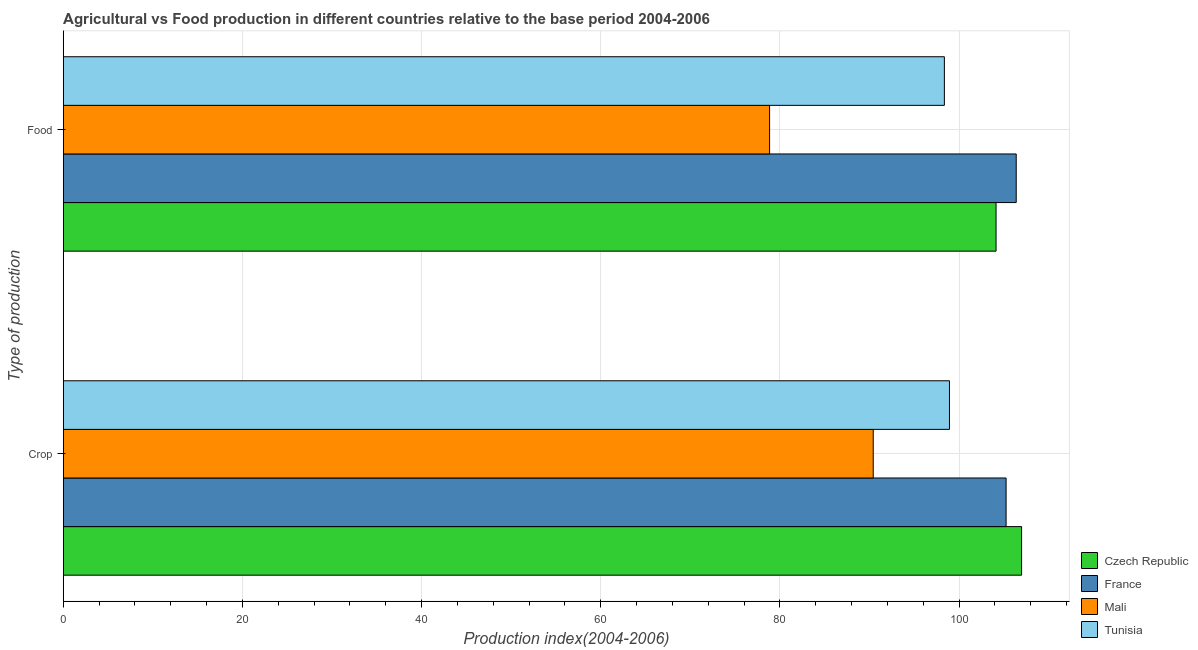Are the number of bars per tick equal to the number of legend labels?
Ensure brevity in your answer.  Yes. Are the number of bars on each tick of the Y-axis equal?
Offer a very short reply. Yes. How many bars are there on the 1st tick from the top?
Offer a terse response. 4. What is the label of the 1st group of bars from the top?
Provide a succinct answer. Food. What is the crop production index in France?
Ensure brevity in your answer.  105.25. Across all countries, what is the maximum food production index?
Offer a terse response. 106.38. Across all countries, what is the minimum food production index?
Your answer should be compact. 78.85. In which country was the food production index maximum?
Provide a short and direct response. France. In which country was the food production index minimum?
Provide a short and direct response. Mali. What is the total crop production index in the graph?
Provide a succinct answer. 401.58. What is the difference between the crop production index in Tunisia and that in Mali?
Make the answer very short. 8.51. What is the difference between the crop production index in Czech Republic and the food production index in France?
Your answer should be compact. 0.6. What is the average food production index per country?
Your response must be concise. 96.93. What is the difference between the crop production index and food production index in Czech Republic?
Offer a terse response. 2.85. In how many countries, is the crop production index greater than 108 ?
Make the answer very short. 0. What is the ratio of the crop production index in France to that in Tunisia?
Give a very brief answer. 1.06. What does the 1st bar from the top in Crop represents?
Your response must be concise. Tunisia. What does the 2nd bar from the bottom in Crop represents?
Provide a succinct answer. France. Are all the bars in the graph horizontal?
Your answer should be very brief. Yes. How many countries are there in the graph?
Your answer should be very brief. 4. What is the difference between two consecutive major ticks on the X-axis?
Provide a short and direct response. 20. Are the values on the major ticks of X-axis written in scientific E-notation?
Give a very brief answer. No. Does the graph contain any zero values?
Your response must be concise. No. Does the graph contain grids?
Offer a very short reply. Yes. How many legend labels are there?
Keep it short and to the point. 4. How are the legend labels stacked?
Offer a very short reply. Vertical. What is the title of the graph?
Ensure brevity in your answer.  Agricultural vs Food production in different countries relative to the base period 2004-2006. Does "Zambia" appear as one of the legend labels in the graph?
Provide a short and direct response. No. What is the label or title of the X-axis?
Keep it short and to the point. Production index(2004-2006). What is the label or title of the Y-axis?
Provide a succinct answer. Type of production. What is the Production index(2004-2006) of Czech Republic in Crop?
Offer a very short reply. 106.98. What is the Production index(2004-2006) of France in Crop?
Keep it short and to the point. 105.25. What is the Production index(2004-2006) of Mali in Crop?
Keep it short and to the point. 90.42. What is the Production index(2004-2006) in Tunisia in Crop?
Ensure brevity in your answer.  98.93. What is the Production index(2004-2006) in Czech Republic in Food?
Your answer should be compact. 104.13. What is the Production index(2004-2006) of France in Food?
Offer a very short reply. 106.38. What is the Production index(2004-2006) in Mali in Food?
Ensure brevity in your answer.  78.85. What is the Production index(2004-2006) of Tunisia in Food?
Your response must be concise. 98.36. Across all Type of production, what is the maximum Production index(2004-2006) of Czech Republic?
Provide a succinct answer. 106.98. Across all Type of production, what is the maximum Production index(2004-2006) of France?
Ensure brevity in your answer.  106.38. Across all Type of production, what is the maximum Production index(2004-2006) in Mali?
Provide a succinct answer. 90.42. Across all Type of production, what is the maximum Production index(2004-2006) of Tunisia?
Provide a succinct answer. 98.93. Across all Type of production, what is the minimum Production index(2004-2006) in Czech Republic?
Make the answer very short. 104.13. Across all Type of production, what is the minimum Production index(2004-2006) in France?
Your answer should be very brief. 105.25. Across all Type of production, what is the minimum Production index(2004-2006) of Mali?
Provide a succinct answer. 78.85. Across all Type of production, what is the minimum Production index(2004-2006) of Tunisia?
Offer a terse response. 98.36. What is the total Production index(2004-2006) of Czech Republic in the graph?
Provide a short and direct response. 211.11. What is the total Production index(2004-2006) of France in the graph?
Keep it short and to the point. 211.63. What is the total Production index(2004-2006) of Mali in the graph?
Keep it short and to the point. 169.27. What is the total Production index(2004-2006) of Tunisia in the graph?
Keep it short and to the point. 197.29. What is the difference between the Production index(2004-2006) of Czech Republic in Crop and that in Food?
Offer a very short reply. 2.85. What is the difference between the Production index(2004-2006) in France in Crop and that in Food?
Your answer should be compact. -1.13. What is the difference between the Production index(2004-2006) of Mali in Crop and that in Food?
Give a very brief answer. 11.57. What is the difference between the Production index(2004-2006) of Tunisia in Crop and that in Food?
Offer a terse response. 0.57. What is the difference between the Production index(2004-2006) of Czech Republic in Crop and the Production index(2004-2006) of Mali in Food?
Your response must be concise. 28.13. What is the difference between the Production index(2004-2006) of Czech Republic in Crop and the Production index(2004-2006) of Tunisia in Food?
Offer a terse response. 8.62. What is the difference between the Production index(2004-2006) of France in Crop and the Production index(2004-2006) of Mali in Food?
Give a very brief answer. 26.4. What is the difference between the Production index(2004-2006) in France in Crop and the Production index(2004-2006) in Tunisia in Food?
Give a very brief answer. 6.89. What is the difference between the Production index(2004-2006) in Mali in Crop and the Production index(2004-2006) in Tunisia in Food?
Offer a terse response. -7.94. What is the average Production index(2004-2006) in Czech Republic per Type of production?
Provide a short and direct response. 105.56. What is the average Production index(2004-2006) in France per Type of production?
Your response must be concise. 105.81. What is the average Production index(2004-2006) of Mali per Type of production?
Provide a short and direct response. 84.64. What is the average Production index(2004-2006) in Tunisia per Type of production?
Your answer should be very brief. 98.64. What is the difference between the Production index(2004-2006) of Czech Republic and Production index(2004-2006) of France in Crop?
Offer a terse response. 1.73. What is the difference between the Production index(2004-2006) in Czech Republic and Production index(2004-2006) in Mali in Crop?
Your response must be concise. 16.56. What is the difference between the Production index(2004-2006) of Czech Republic and Production index(2004-2006) of Tunisia in Crop?
Provide a succinct answer. 8.05. What is the difference between the Production index(2004-2006) in France and Production index(2004-2006) in Mali in Crop?
Your answer should be very brief. 14.83. What is the difference between the Production index(2004-2006) in France and Production index(2004-2006) in Tunisia in Crop?
Your response must be concise. 6.32. What is the difference between the Production index(2004-2006) of Mali and Production index(2004-2006) of Tunisia in Crop?
Make the answer very short. -8.51. What is the difference between the Production index(2004-2006) of Czech Republic and Production index(2004-2006) of France in Food?
Give a very brief answer. -2.25. What is the difference between the Production index(2004-2006) in Czech Republic and Production index(2004-2006) in Mali in Food?
Your response must be concise. 25.28. What is the difference between the Production index(2004-2006) in Czech Republic and Production index(2004-2006) in Tunisia in Food?
Give a very brief answer. 5.77. What is the difference between the Production index(2004-2006) in France and Production index(2004-2006) in Mali in Food?
Make the answer very short. 27.53. What is the difference between the Production index(2004-2006) in France and Production index(2004-2006) in Tunisia in Food?
Provide a short and direct response. 8.02. What is the difference between the Production index(2004-2006) of Mali and Production index(2004-2006) of Tunisia in Food?
Offer a very short reply. -19.51. What is the ratio of the Production index(2004-2006) of Czech Republic in Crop to that in Food?
Your response must be concise. 1.03. What is the ratio of the Production index(2004-2006) of Mali in Crop to that in Food?
Make the answer very short. 1.15. What is the difference between the highest and the second highest Production index(2004-2006) in Czech Republic?
Keep it short and to the point. 2.85. What is the difference between the highest and the second highest Production index(2004-2006) in France?
Offer a terse response. 1.13. What is the difference between the highest and the second highest Production index(2004-2006) of Mali?
Keep it short and to the point. 11.57. What is the difference between the highest and the second highest Production index(2004-2006) in Tunisia?
Your answer should be compact. 0.57. What is the difference between the highest and the lowest Production index(2004-2006) of Czech Republic?
Provide a succinct answer. 2.85. What is the difference between the highest and the lowest Production index(2004-2006) of France?
Offer a terse response. 1.13. What is the difference between the highest and the lowest Production index(2004-2006) in Mali?
Offer a very short reply. 11.57. What is the difference between the highest and the lowest Production index(2004-2006) in Tunisia?
Ensure brevity in your answer.  0.57. 